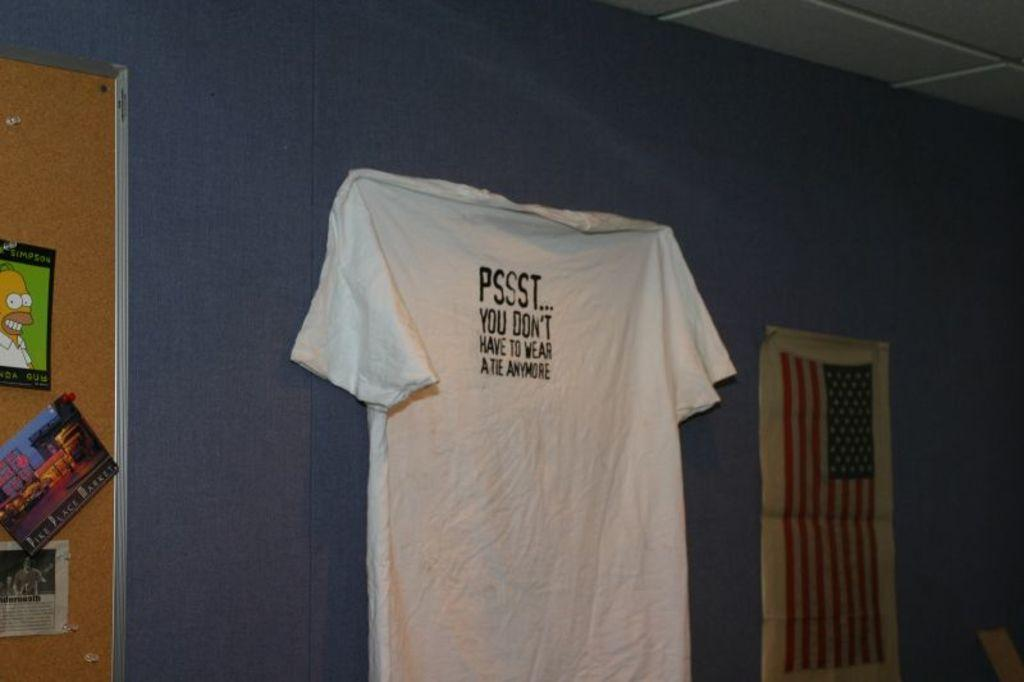<image>
Describe the image concisely. A SIMPSON poster can be seen hanging on the wall. 